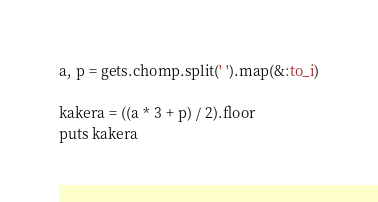Convert code to text. <code><loc_0><loc_0><loc_500><loc_500><_Ruby_>a, p = gets.chomp.split(' ').map(&:to_i)

kakera = ((a * 3 + p) / 2).floor
puts kakera</code> 